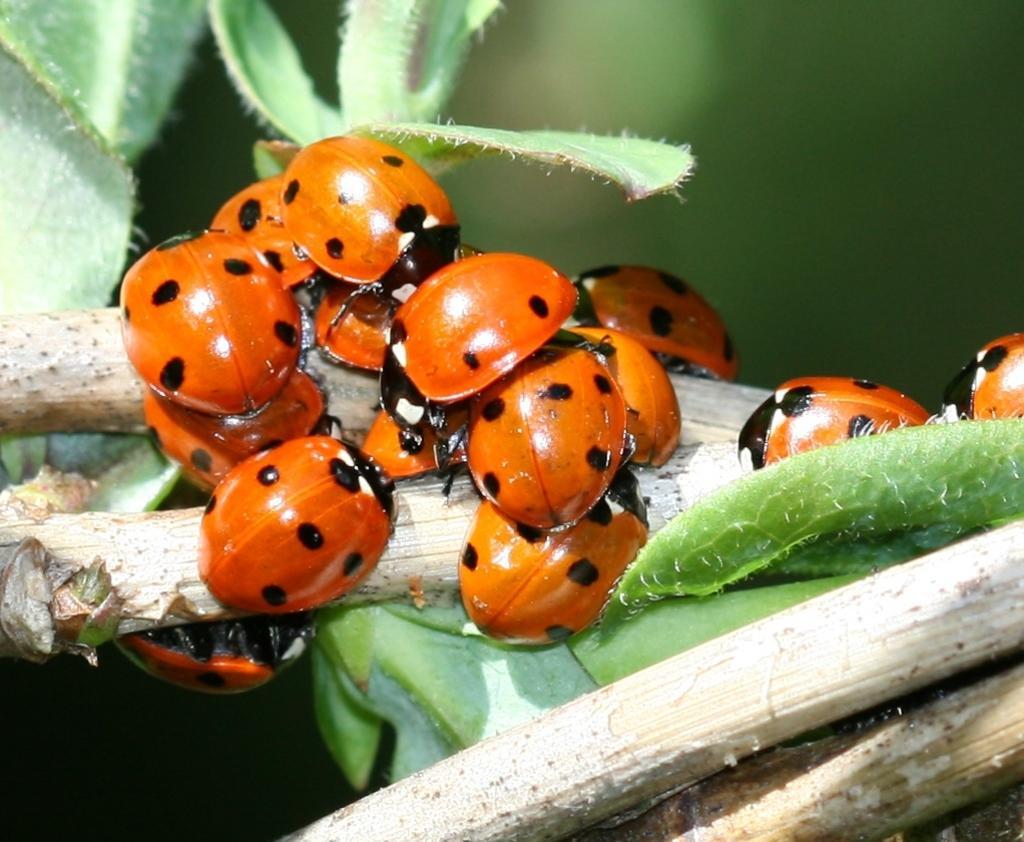Can you describe this image briefly? In this image I can see some insects which are in orange color and I can see black color marks on that. These are placed on a plant. I can see the leaves in green color and the stems in white color. The background is blurred. 